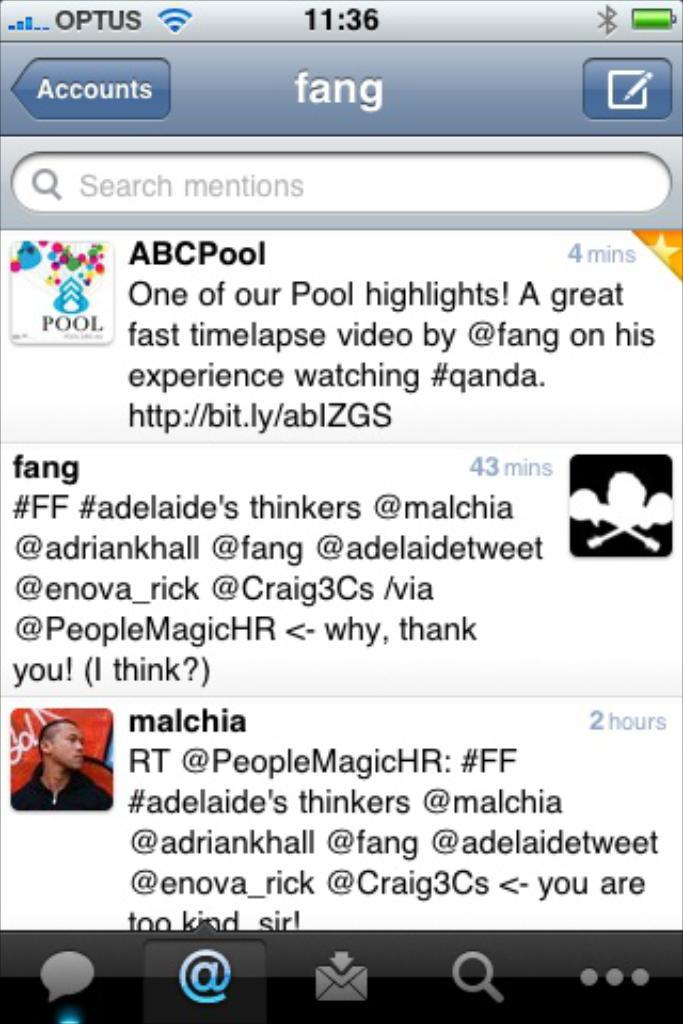What type of image is shown in the screenshot? The image is a screenshot of a phone screen. What can be seen on the phone screen? There is text, logos, and an image of a person visible on the phone screen. How many rings are being distributed by the person in the image? There is no person distributing rings in the image; it only shows a screenshot of a phone screen with text, logos, and an image of a person. 